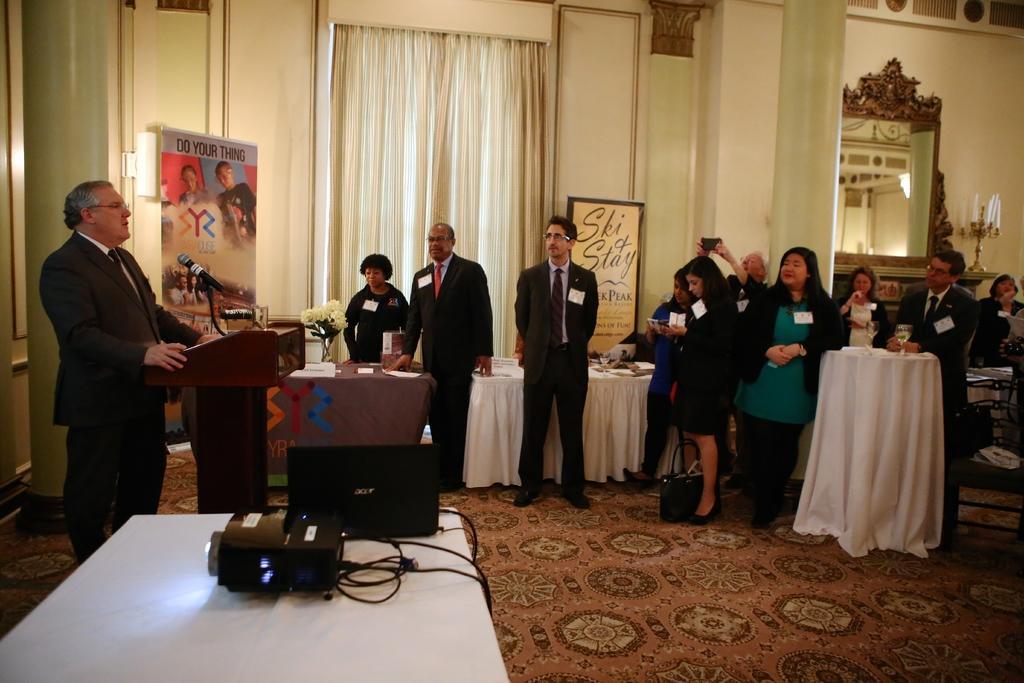How would you summarize this image in a sentence or two? In the picture, it looks like a conference room , there are many people standing in front of that there is a table and in front of the table a person is standing and talking, to his right side there is a projector machine and a laptop on the table, to his left side there are few other tables, in the background there is a wall and to the wall there are some posters attached,to the right side of the wall there is a pillar and beside the pillar there is a mirror. 